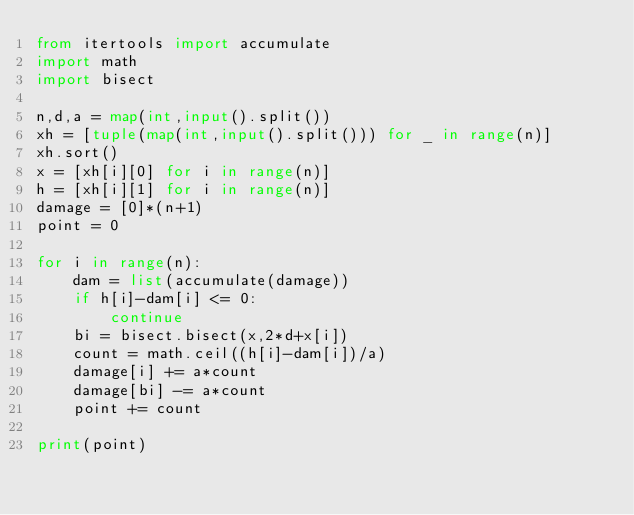Convert code to text. <code><loc_0><loc_0><loc_500><loc_500><_Python_>from itertools import accumulate
import math
import bisect

n,d,a = map(int,input().split())
xh = [tuple(map(int,input().split())) for _ in range(n)]
xh.sort()
x = [xh[i][0] for i in range(n)]
h = [xh[i][1] for i in range(n)]
damage = [0]*(n+1)
point = 0

for i in range(n):
    dam = list(accumulate(damage))
    if h[i]-dam[i] <= 0:
        continue
    bi = bisect.bisect(x,2*d+x[i])
    count = math.ceil((h[i]-dam[i])/a)
    damage[i] += a*count
    damage[bi] -= a*count
    point += count

print(point)</code> 